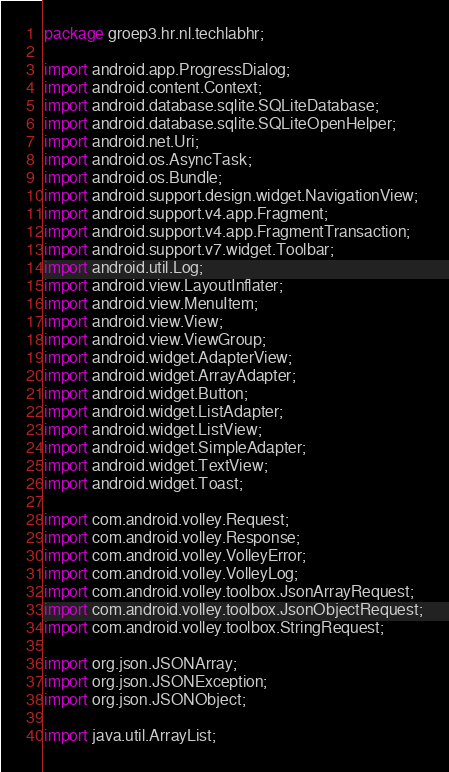<code> <loc_0><loc_0><loc_500><loc_500><_Java_>package groep3.hr.nl.techlabhr;

import android.app.ProgressDialog;
import android.content.Context;
import android.database.sqlite.SQLiteDatabase;
import android.database.sqlite.SQLiteOpenHelper;
import android.net.Uri;
import android.os.AsyncTask;
import android.os.Bundle;
import android.support.design.widget.NavigationView;
import android.support.v4.app.Fragment;
import android.support.v4.app.FragmentTransaction;
import android.support.v7.widget.Toolbar;
import android.util.Log;
import android.view.LayoutInflater;
import android.view.MenuItem;
import android.view.View;
import android.view.ViewGroup;
import android.widget.AdapterView;
import android.widget.ArrayAdapter;
import android.widget.Button;
import android.widget.ListAdapter;
import android.widget.ListView;
import android.widget.SimpleAdapter;
import android.widget.TextView;
import android.widget.Toast;

import com.android.volley.Request;
import com.android.volley.Response;
import com.android.volley.VolleyError;
import com.android.volley.VolleyLog;
import com.android.volley.toolbox.JsonArrayRequest;
import com.android.volley.toolbox.JsonObjectRequest;
import com.android.volley.toolbox.StringRequest;

import org.json.JSONArray;
import org.json.JSONException;
import org.json.JSONObject;

import java.util.ArrayList;</code> 